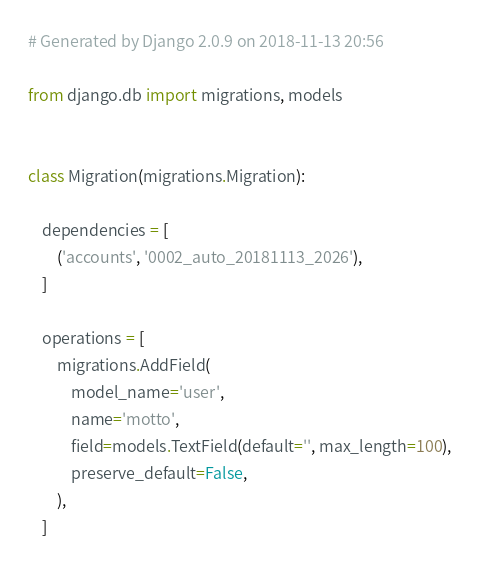<code> <loc_0><loc_0><loc_500><loc_500><_Python_># Generated by Django 2.0.9 on 2018-11-13 20:56

from django.db import migrations, models


class Migration(migrations.Migration):

    dependencies = [
        ('accounts', '0002_auto_20181113_2026'),
    ]

    operations = [
        migrations.AddField(
            model_name='user',
            name='motto',
            field=models.TextField(default='', max_length=100),
            preserve_default=False,
        ),
    ]
</code> 